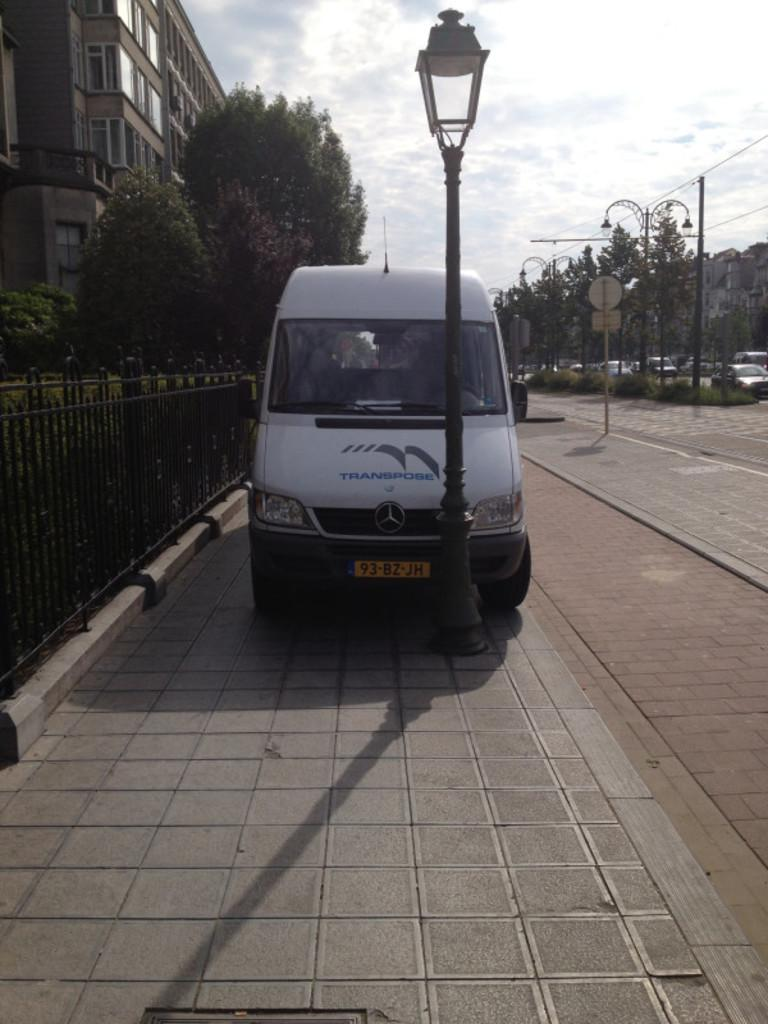<image>
Write a terse but informative summary of the picture. A white van parked on the sidewalk has a license plate that reads 93-BZ-JH. 